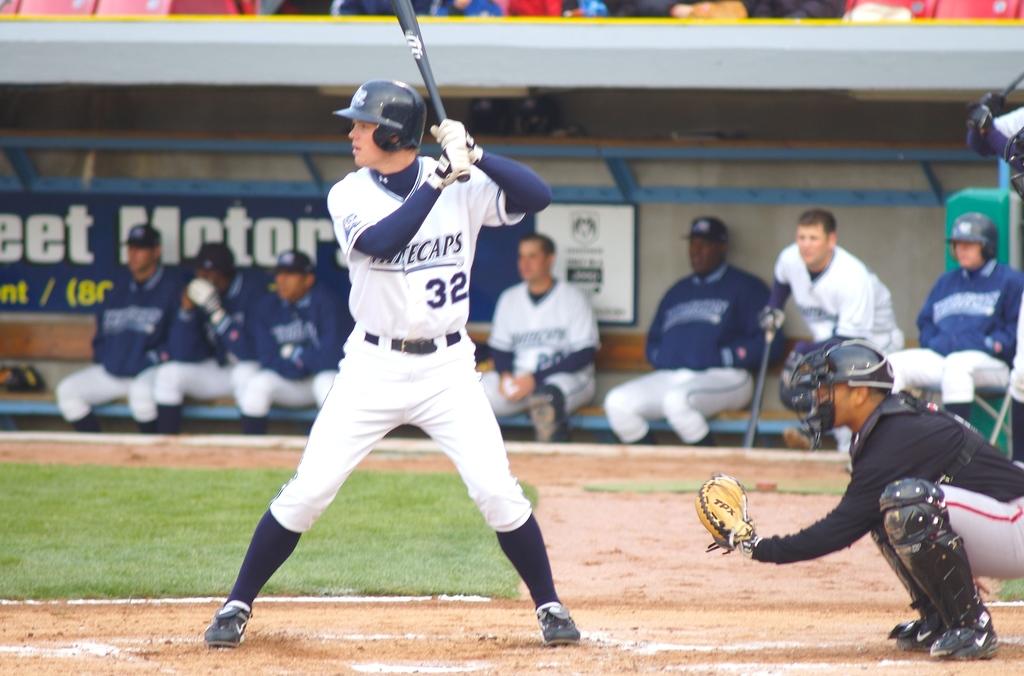What is the number of the player batting?
Your answer should be very brief. 32. Who is the player holding the bat?
Offer a very short reply. 32. 